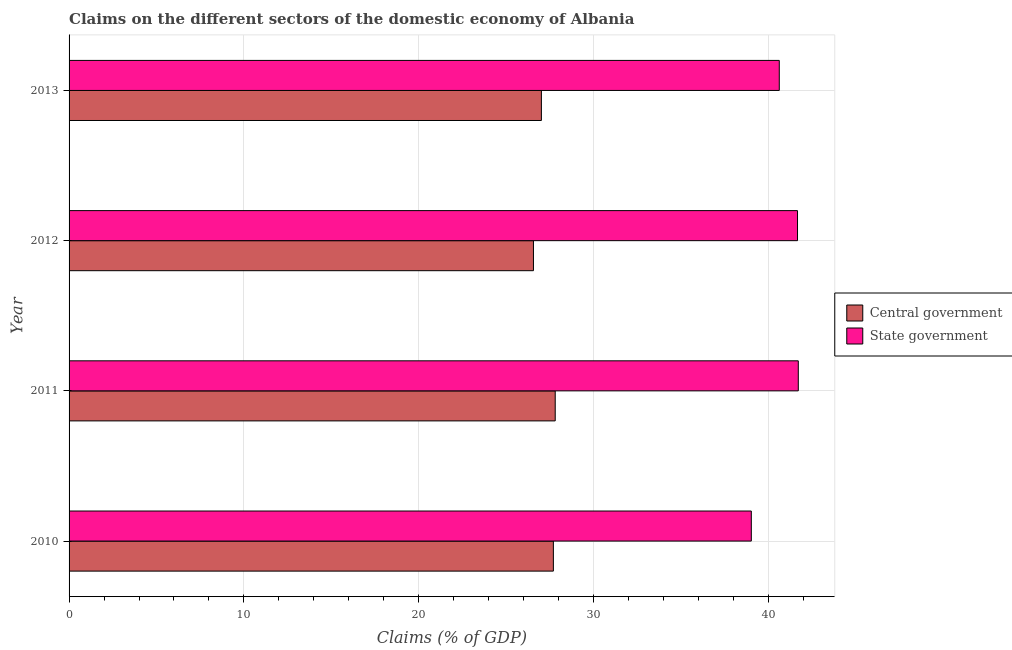How many different coloured bars are there?
Offer a terse response. 2. Are the number of bars on each tick of the Y-axis equal?
Your answer should be very brief. Yes. How many bars are there on the 2nd tick from the top?
Your answer should be compact. 2. How many bars are there on the 1st tick from the bottom?
Your response must be concise. 2. What is the label of the 2nd group of bars from the top?
Make the answer very short. 2012. What is the claims on state government in 2012?
Your answer should be very brief. 41.67. Across all years, what is the maximum claims on central government?
Provide a short and direct response. 27.81. Across all years, what is the minimum claims on state government?
Your answer should be compact. 39.02. In which year was the claims on state government minimum?
Keep it short and to the point. 2010. What is the total claims on state government in the graph?
Ensure brevity in your answer.  163.02. What is the difference between the claims on central government in 2010 and that in 2012?
Ensure brevity in your answer.  1.14. What is the difference between the claims on state government in 2013 and the claims on central government in 2010?
Give a very brief answer. 12.92. What is the average claims on central government per year?
Keep it short and to the point. 27.27. In the year 2011, what is the difference between the claims on central government and claims on state government?
Provide a succinct answer. -13.9. In how many years, is the claims on central government greater than 18 %?
Give a very brief answer. 4. What is the ratio of the claims on state government in 2011 to that in 2012?
Offer a terse response. 1. Is the claims on state government in 2012 less than that in 2013?
Your answer should be compact. No. Is the difference between the claims on state government in 2011 and 2012 greater than the difference between the claims on central government in 2011 and 2012?
Your answer should be compact. No. What is the difference between the highest and the second highest claims on state government?
Give a very brief answer. 0.04. What is the difference between the highest and the lowest claims on state government?
Your answer should be very brief. 2.69. In how many years, is the claims on state government greater than the average claims on state government taken over all years?
Make the answer very short. 2. What does the 1st bar from the top in 2012 represents?
Keep it short and to the point. State government. What does the 1st bar from the bottom in 2013 represents?
Your answer should be compact. Central government. How many bars are there?
Offer a terse response. 8. Are all the bars in the graph horizontal?
Offer a very short reply. Yes. How many years are there in the graph?
Keep it short and to the point. 4. Are the values on the major ticks of X-axis written in scientific E-notation?
Your answer should be compact. No. Does the graph contain any zero values?
Your answer should be compact. No. Does the graph contain grids?
Keep it short and to the point. Yes. Where does the legend appear in the graph?
Your answer should be compact. Center right. How many legend labels are there?
Offer a terse response. 2. What is the title of the graph?
Provide a short and direct response. Claims on the different sectors of the domestic economy of Albania. Does "Infant" appear as one of the legend labels in the graph?
Provide a short and direct response. No. What is the label or title of the X-axis?
Your answer should be compact. Claims (% of GDP). What is the label or title of the Y-axis?
Your answer should be very brief. Year. What is the Claims (% of GDP) of Central government in 2010?
Offer a very short reply. 27.7. What is the Claims (% of GDP) of State government in 2010?
Offer a terse response. 39.02. What is the Claims (% of GDP) of Central government in 2011?
Offer a very short reply. 27.81. What is the Claims (% of GDP) in State government in 2011?
Offer a terse response. 41.71. What is the Claims (% of GDP) of Central government in 2012?
Provide a short and direct response. 26.56. What is the Claims (% of GDP) in State government in 2012?
Your answer should be very brief. 41.67. What is the Claims (% of GDP) of Central government in 2013?
Ensure brevity in your answer.  27.02. What is the Claims (% of GDP) of State government in 2013?
Keep it short and to the point. 40.62. Across all years, what is the maximum Claims (% of GDP) in Central government?
Ensure brevity in your answer.  27.81. Across all years, what is the maximum Claims (% of GDP) of State government?
Make the answer very short. 41.71. Across all years, what is the minimum Claims (% of GDP) in Central government?
Provide a succinct answer. 26.56. Across all years, what is the minimum Claims (% of GDP) in State government?
Offer a terse response. 39.02. What is the total Claims (% of GDP) of Central government in the graph?
Keep it short and to the point. 109.09. What is the total Claims (% of GDP) in State government in the graph?
Ensure brevity in your answer.  163.02. What is the difference between the Claims (% of GDP) in Central government in 2010 and that in 2011?
Keep it short and to the point. -0.11. What is the difference between the Claims (% of GDP) in State government in 2010 and that in 2011?
Your response must be concise. -2.69. What is the difference between the Claims (% of GDP) of Central government in 2010 and that in 2012?
Your answer should be very brief. 1.14. What is the difference between the Claims (% of GDP) of State government in 2010 and that in 2012?
Offer a very short reply. -2.64. What is the difference between the Claims (% of GDP) in Central government in 2010 and that in 2013?
Keep it short and to the point. 0.69. What is the difference between the Claims (% of GDP) of State government in 2010 and that in 2013?
Your answer should be compact. -1.6. What is the difference between the Claims (% of GDP) in Central government in 2011 and that in 2012?
Your answer should be compact. 1.24. What is the difference between the Claims (% of GDP) of State government in 2011 and that in 2012?
Your answer should be compact. 0.04. What is the difference between the Claims (% of GDP) in Central government in 2011 and that in 2013?
Your answer should be very brief. 0.79. What is the difference between the Claims (% of GDP) of State government in 2011 and that in 2013?
Offer a very short reply. 1.09. What is the difference between the Claims (% of GDP) of Central government in 2012 and that in 2013?
Keep it short and to the point. -0.45. What is the difference between the Claims (% of GDP) in State government in 2012 and that in 2013?
Keep it short and to the point. 1.04. What is the difference between the Claims (% of GDP) of Central government in 2010 and the Claims (% of GDP) of State government in 2011?
Ensure brevity in your answer.  -14.01. What is the difference between the Claims (% of GDP) in Central government in 2010 and the Claims (% of GDP) in State government in 2012?
Offer a very short reply. -13.96. What is the difference between the Claims (% of GDP) of Central government in 2010 and the Claims (% of GDP) of State government in 2013?
Give a very brief answer. -12.92. What is the difference between the Claims (% of GDP) in Central government in 2011 and the Claims (% of GDP) in State government in 2012?
Give a very brief answer. -13.86. What is the difference between the Claims (% of GDP) of Central government in 2011 and the Claims (% of GDP) of State government in 2013?
Ensure brevity in your answer.  -12.82. What is the difference between the Claims (% of GDP) of Central government in 2012 and the Claims (% of GDP) of State government in 2013?
Your answer should be very brief. -14.06. What is the average Claims (% of GDP) in Central government per year?
Ensure brevity in your answer.  27.27. What is the average Claims (% of GDP) in State government per year?
Ensure brevity in your answer.  40.76. In the year 2010, what is the difference between the Claims (% of GDP) of Central government and Claims (% of GDP) of State government?
Offer a very short reply. -11.32. In the year 2011, what is the difference between the Claims (% of GDP) in Central government and Claims (% of GDP) in State government?
Your response must be concise. -13.9. In the year 2012, what is the difference between the Claims (% of GDP) in Central government and Claims (% of GDP) in State government?
Offer a terse response. -15.1. In the year 2013, what is the difference between the Claims (% of GDP) of Central government and Claims (% of GDP) of State government?
Give a very brief answer. -13.61. What is the ratio of the Claims (% of GDP) of State government in 2010 to that in 2011?
Your response must be concise. 0.94. What is the ratio of the Claims (% of GDP) of Central government in 2010 to that in 2012?
Make the answer very short. 1.04. What is the ratio of the Claims (% of GDP) in State government in 2010 to that in 2012?
Give a very brief answer. 0.94. What is the ratio of the Claims (% of GDP) of Central government in 2010 to that in 2013?
Ensure brevity in your answer.  1.03. What is the ratio of the Claims (% of GDP) of State government in 2010 to that in 2013?
Provide a short and direct response. 0.96. What is the ratio of the Claims (% of GDP) of Central government in 2011 to that in 2012?
Ensure brevity in your answer.  1.05. What is the ratio of the Claims (% of GDP) of Central government in 2011 to that in 2013?
Your answer should be compact. 1.03. What is the ratio of the Claims (% of GDP) in State government in 2011 to that in 2013?
Your response must be concise. 1.03. What is the ratio of the Claims (% of GDP) in Central government in 2012 to that in 2013?
Your response must be concise. 0.98. What is the ratio of the Claims (% of GDP) of State government in 2012 to that in 2013?
Your response must be concise. 1.03. What is the difference between the highest and the second highest Claims (% of GDP) in Central government?
Make the answer very short. 0.11. What is the difference between the highest and the second highest Claims (% of GDP) in State government?
Give a very brief answer. 0.04. What is the difference between the highest and the lowest Claims (% of GDP) in Central government?
Offer a very short reply. 1.24. What is the difference between the highest and the lowest Claims (% of GDP) of State government?
Your answer should be compact. 2.69. 